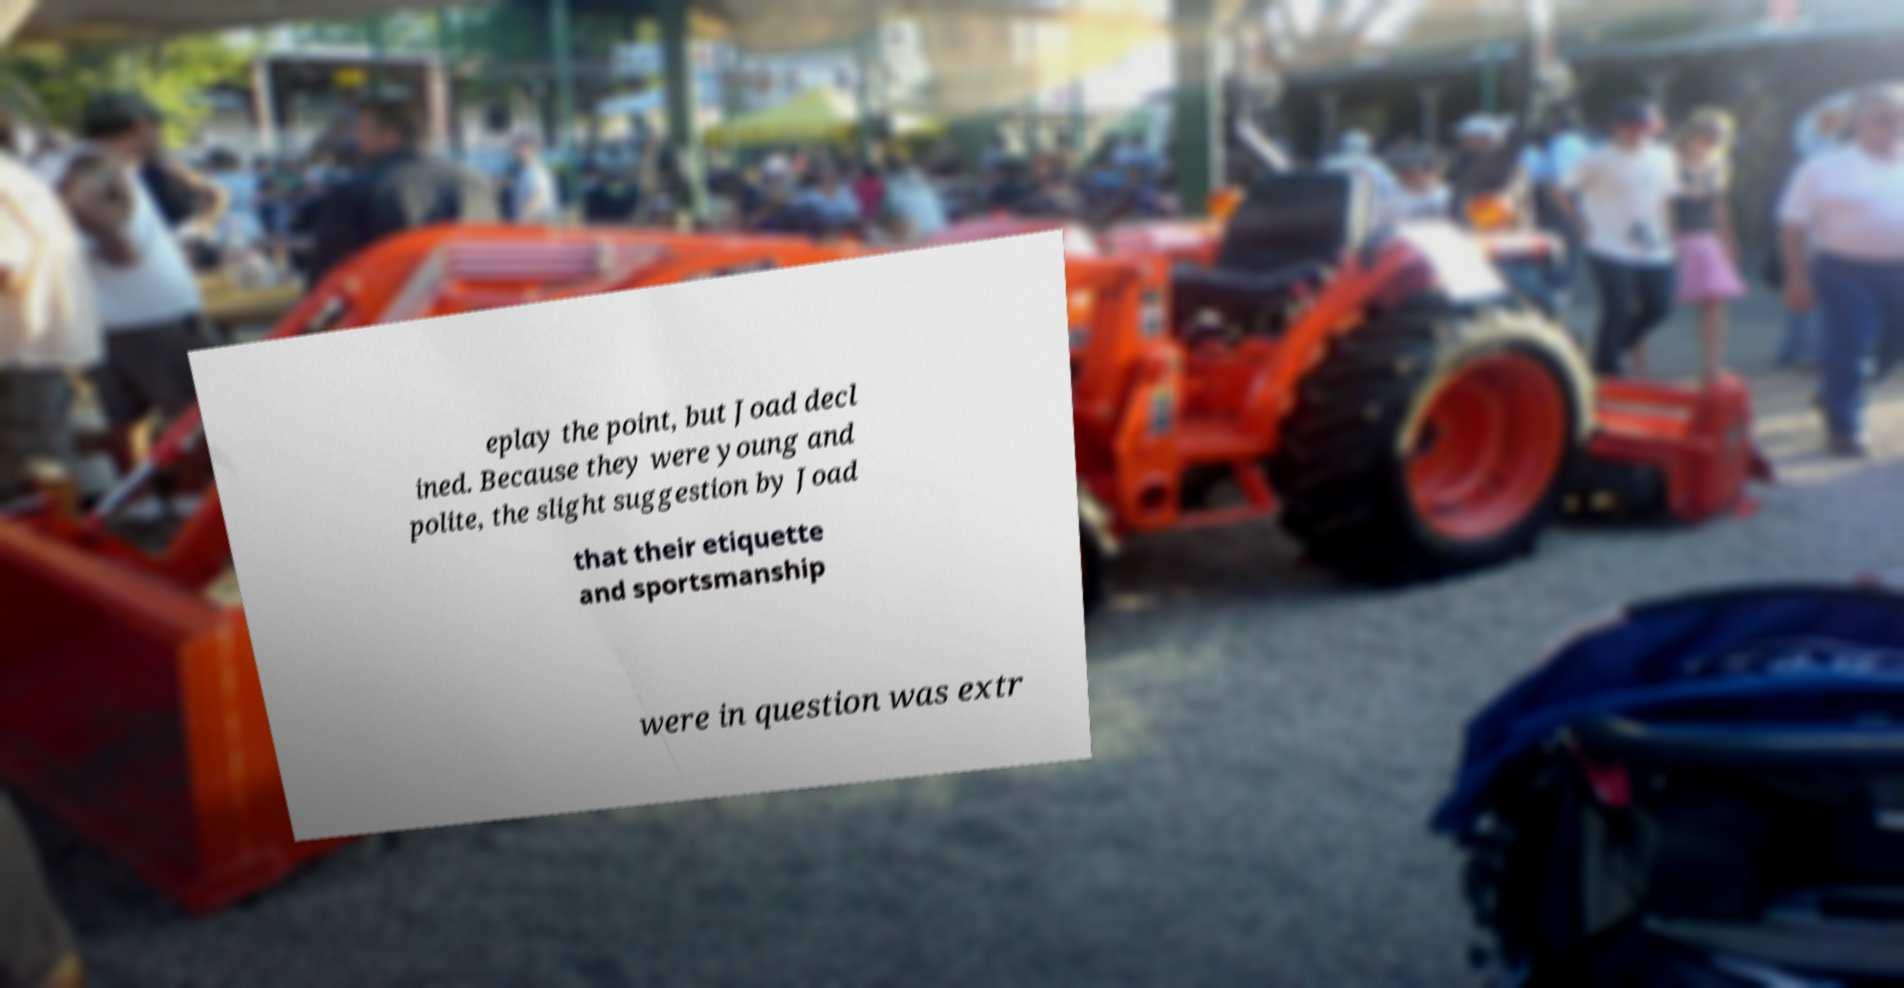I need the written content from this picture converted into text. Can you do that? eplay the point, but Joad decl ined. Because they were young and polite, the slight suggestion by Joad that their etiquette and sportsmanship were in question was extr 